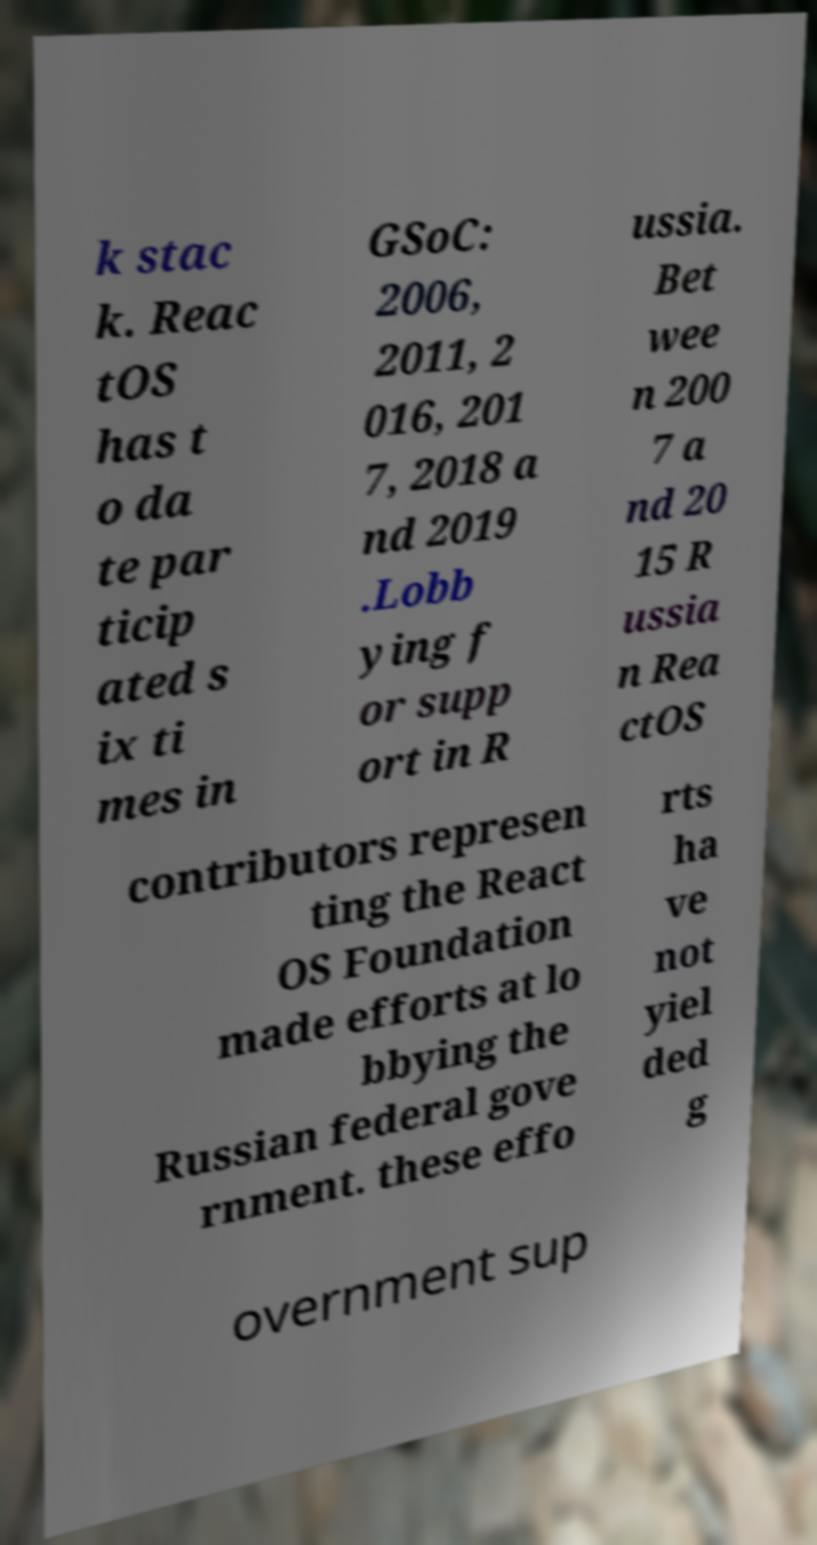There's text embedded in this image that I need extracted. Can you transcribe it verbatim? k stac k. Reac tOS has t o da te par ticip ated s ix ti mes in GSoC: 2006, 2011, 2 016, 201 7, 2018 a nd 2019 .Lobb ying f or supp ort in R ussia. Bet wee n 200 7 a nd 20 15 R ussia n Rea ctOS contributors represen ting the React OS Foundation made efforts at lo bbying the Russian federal gove rnment. these effo rts ha ve not yiel ded g overnment sup 